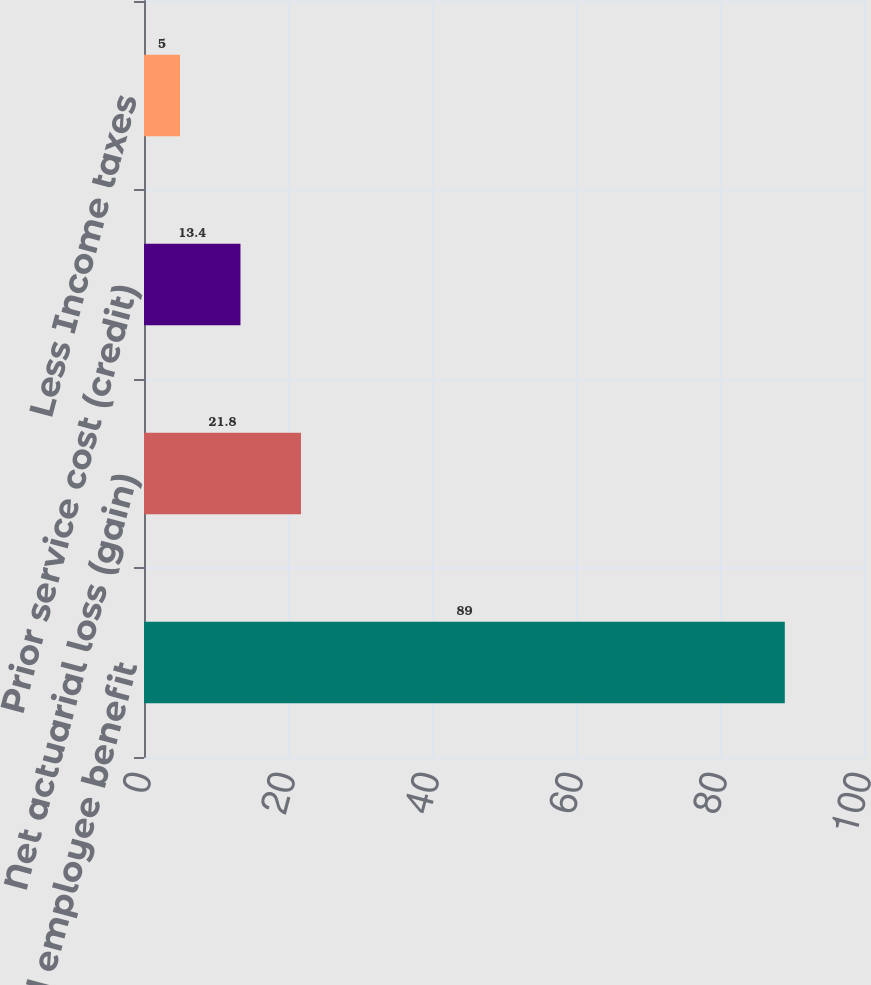Convert chart to OTSL. <chart><loc_0><loc_0><loc_500><loc_500><bar_chart><fcel>Accrued employee benefit<fcel>Net actuarial loss (gain)<fcel>Prior service cost (credit)<fcel>Less Income taxes<nl><fcel>89<fcel>21.8<fcel>13.4<fcel>5<nl></chart> 